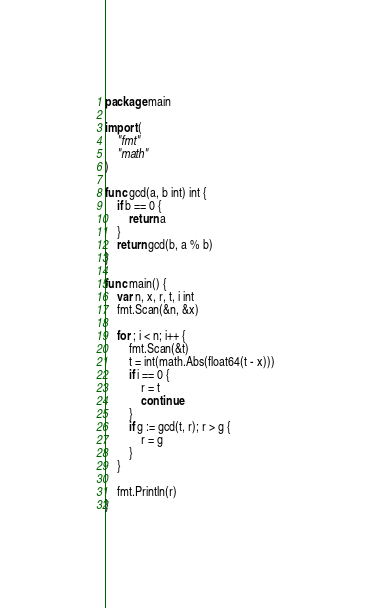<code> <loc_0><loc_0><loc_500><loc_500><_Go_>package main

import (
	"fmt"
	"math"
)

func gcd(a, b int) int {
	if b == 0 {
		return a
	}
	return gcd(b, a % b)
}

func main() {
	var n, x, r, t, i int
	fmt.Scan(&n, &x)

	for ; i < n; i++ {
		fmt.Scan(&t)
		t = int(math.Abs(float64(t - x)))
		if i == 0 {
			r = t
			continue
		}
		if g := gcd(t, r); r > g {
			r = g
		}
	}

	fmt.Println(r)
}</code> 